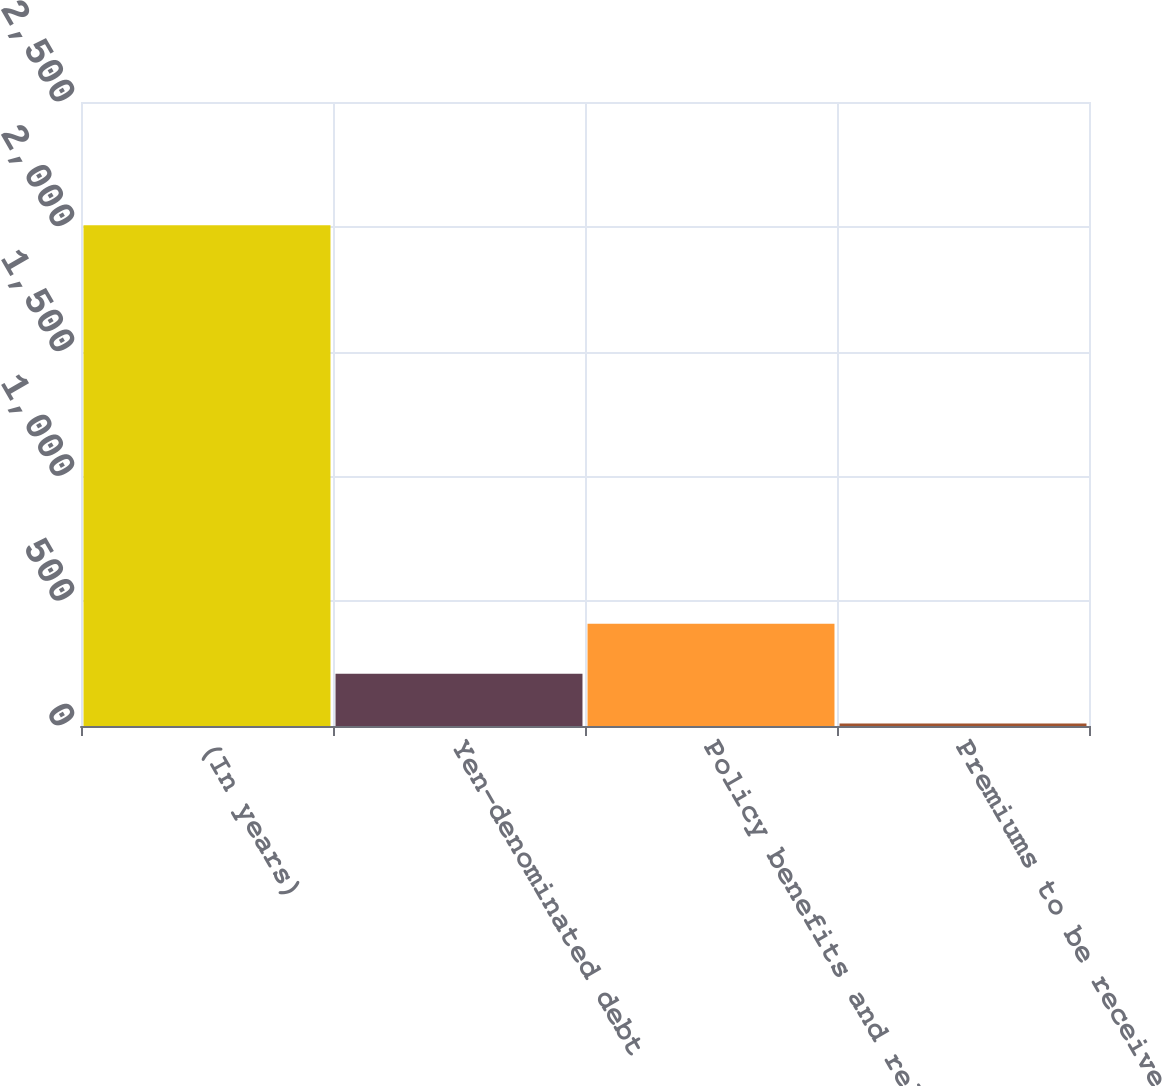<chart> <loc_0><loc_0><loc_500><loc_500><bar_chart><fcel>(In years)<fcel>Yen-denominated debt<fcel>Policy benefits and related<fcel>Premiums to be received in<nl><fcel>2006<fcel>209.6<fcel>409.2<fcel>10<nl></chart> 